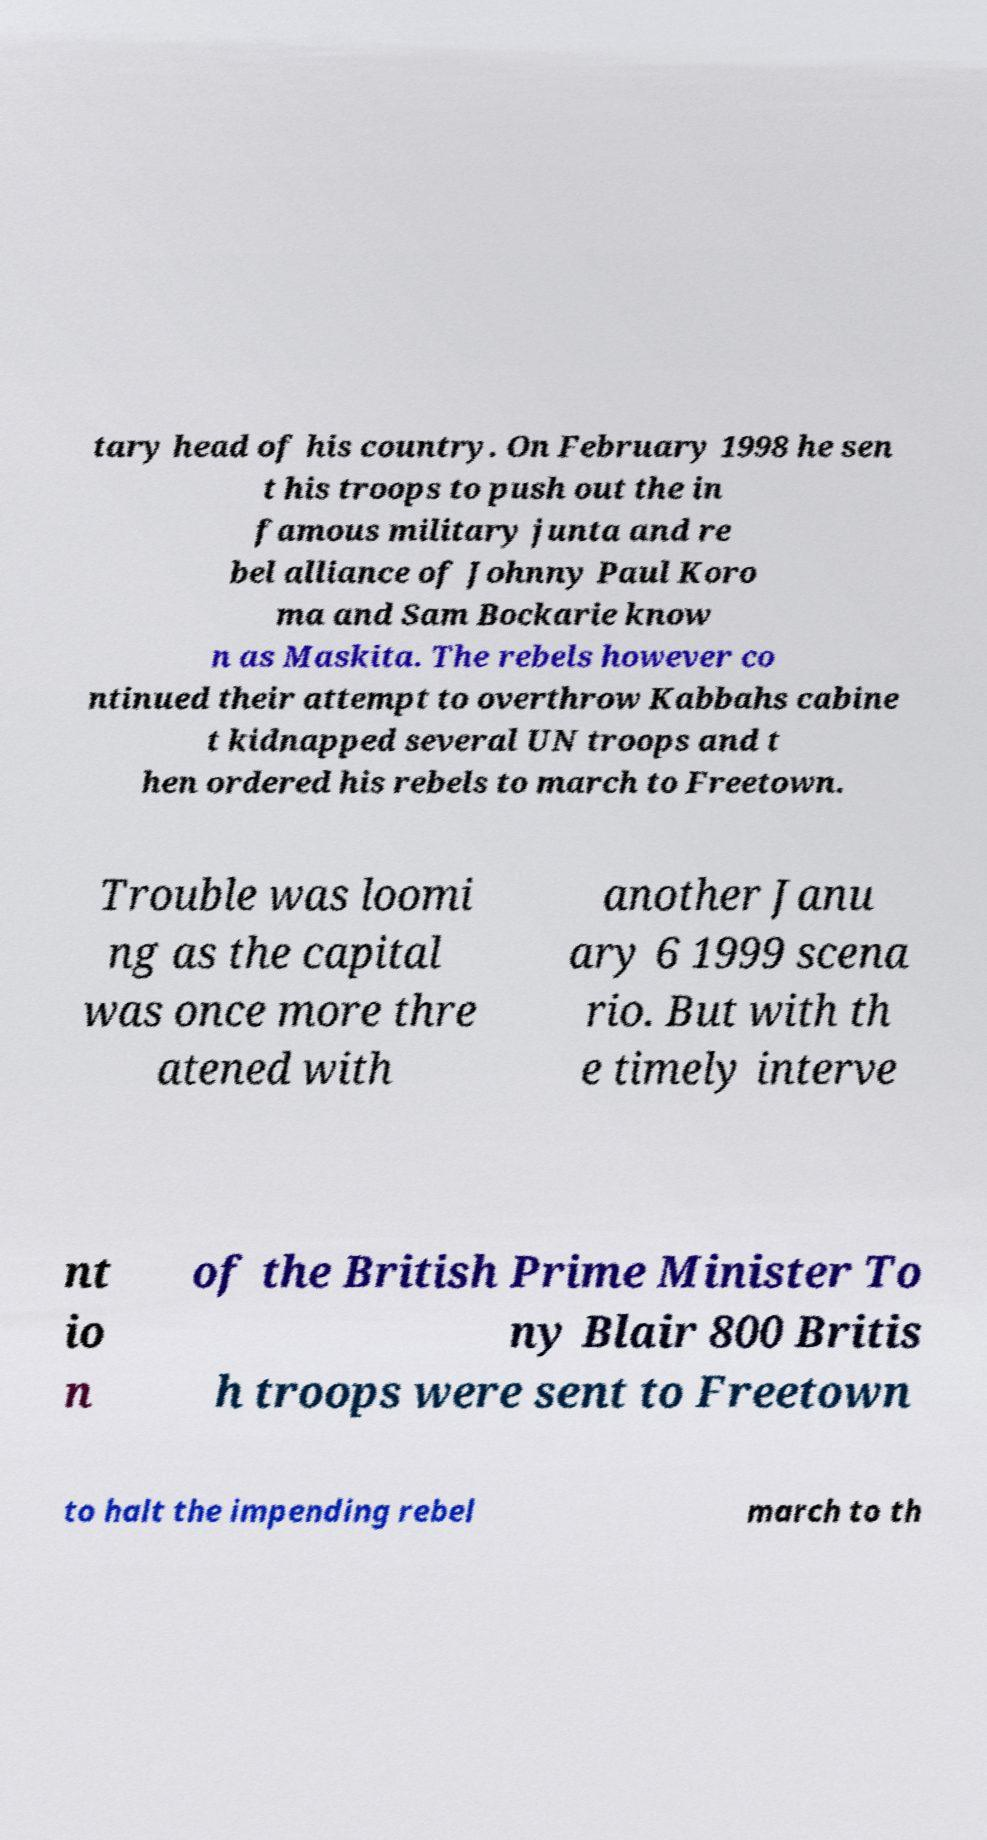Could you assist in decoding the text presented in this image and type it out clearly? tary head of his country. On February 1998 he sen t his troops to push out the in famous military junta and re bel alliance of Johnny Paul Koro ma and Sam Bockarie know n as Maskita. The rebels however co ntinued their attempt to overthrow Kabbahs cabine t kidnapped several UN troops and t hen ordered his rebels to march to Freetown. Trouble was loomi ng as the capital was once more thre atened with another Janu ary 6 1999 scena rio. But with th e timely interve nt io n of the British Prime Minister To ny Blair 800 Britis h troops were sent to Freetown to halt the impending rebel march to th 